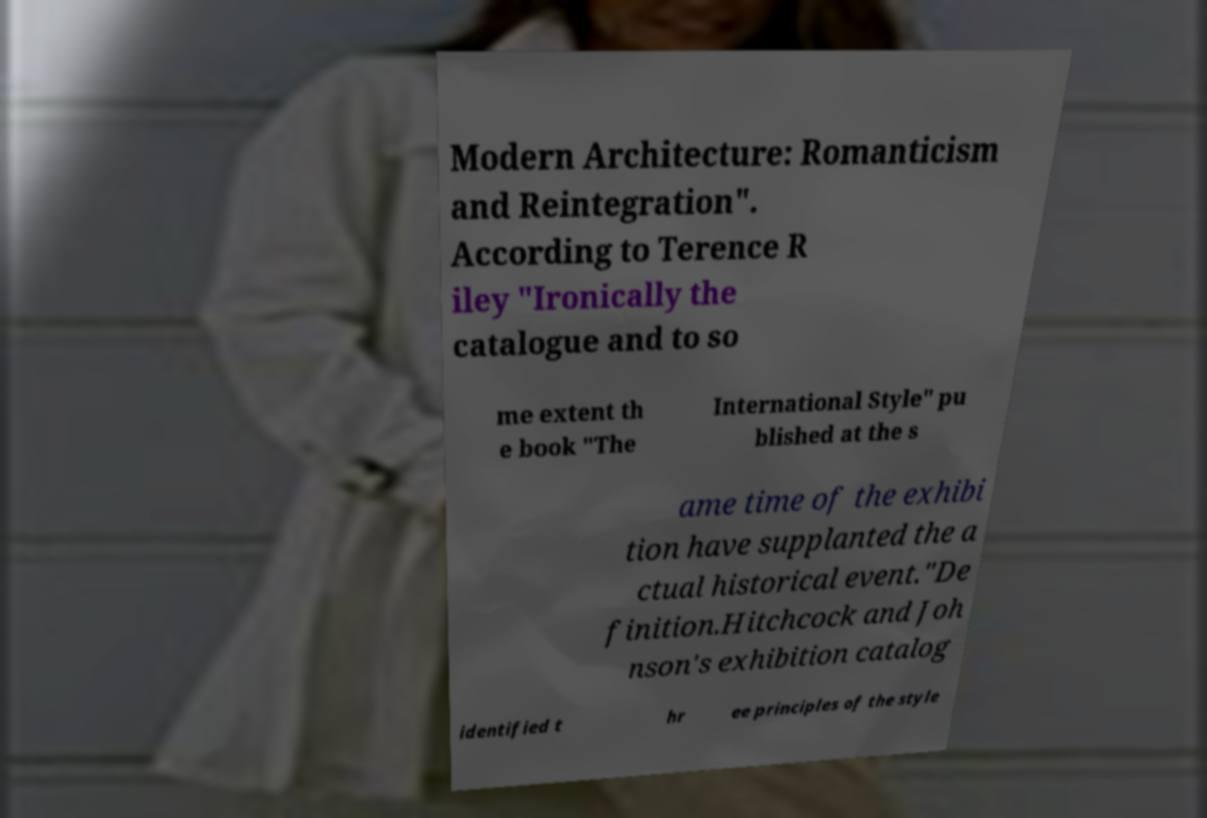Please identify and transcribe the text found in this image. Modern Architecture: Romanticism and Reintegration". According to Terence R iley "Ironically the catalogue and to so me extent th e book "The International Style" pu blished at the s ame time of the exhibi tion have supplanted the a ctual historical event."De finition.Hitchcock and Joh nson's exhibition catalog identified t hr ee principles of the style 